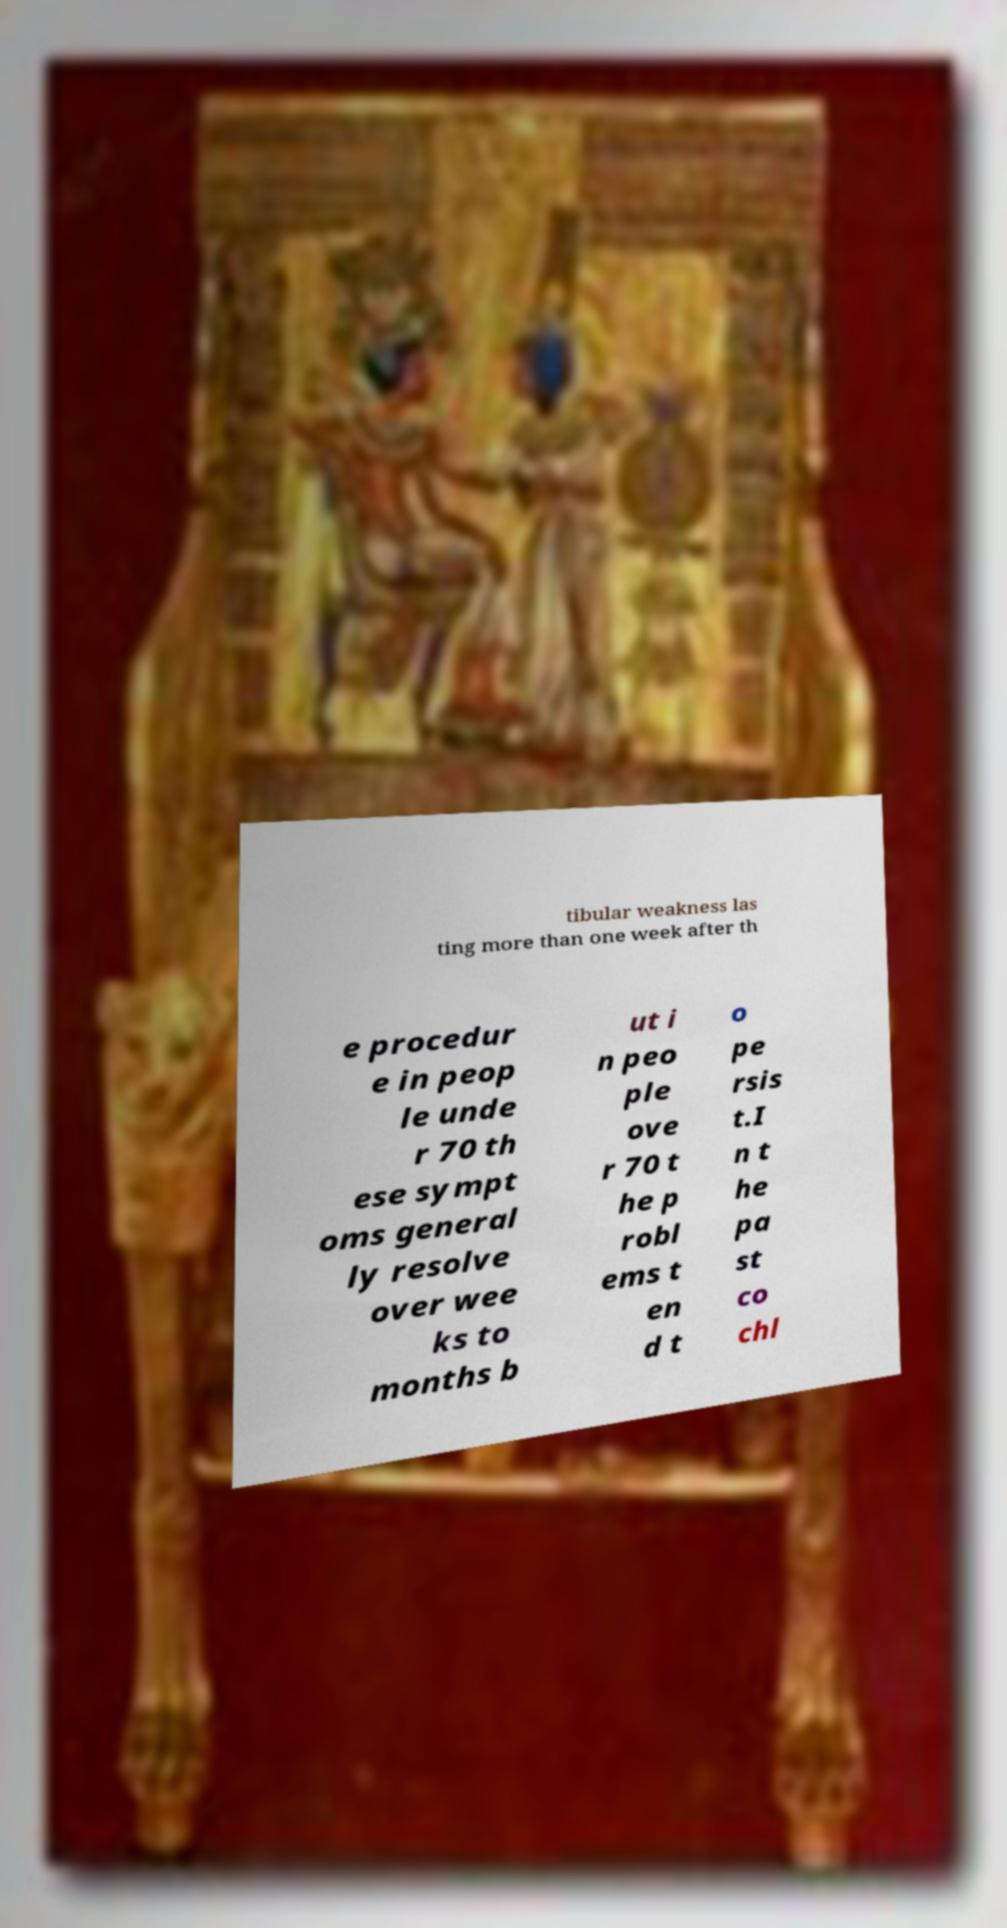Could you extract and type out the text from this image? tibular weakness las ting more than one week after th e procedur e in peop le unde r 70 th ese sympt oms general ly resolve over wee ks to months b ut i n peo ple ove r 70 t he p robl ems t en d t o pe rsis t.I n t he pa st co chl 